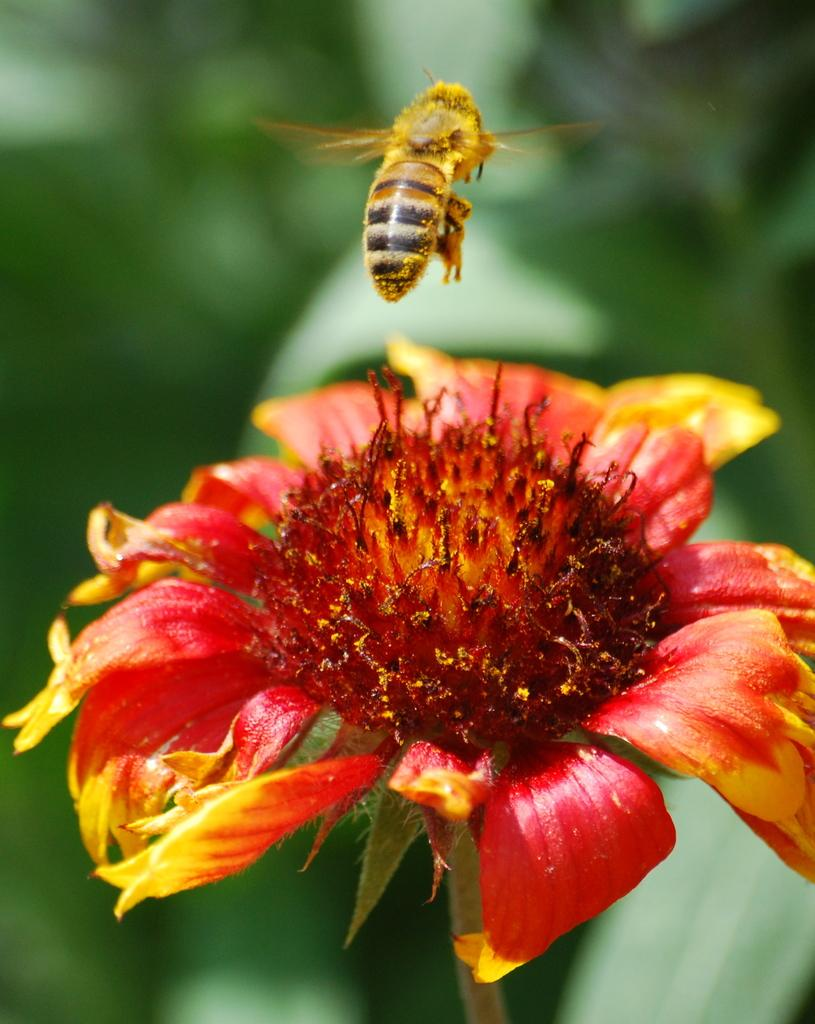What is the main subject of the image? There is a flower in the image. Are there any other living organisms present in the image? Yes, there is a honey bee in the image. Can you describe the background of the image? The background of the image is blurred. What type of grape is being used as a prop in the image? There is no grape present in the image; it features a flower and a honey bee. Can you tell me how the queen is interacting with the flower in the image? There is no queen present in the image; it only features a flower and a honey bee. 